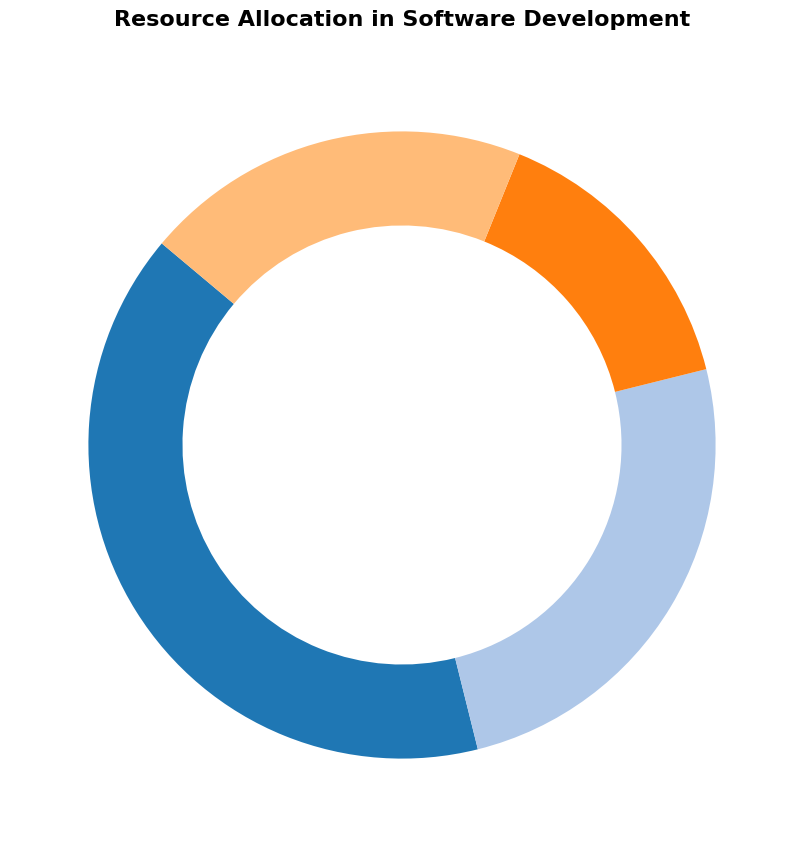What's the largest portion allocated to any activity? By looking at the pie chart, you can see that Development has the largest wedge, representing 40% of the total allocation.
Answer: Development, 40% What's the total percentage allocated to Testing and Deployment? Add the percentages for Testing (25%) and Deployment (15%). The total allocation for these two activities is 25% + 15% = 40%.
Answer: 40% What is the smallest allocation among the activities? By viewing each wedge, Deployment has the smallest allocation at 15%.
Answer: Deployment, 15% Which activity has a greater allocation: Maintenance or Testing? Compare the percentages of Maintenance (20%) and Testing (25%). Testing has a greater allocation.
Answer: Testing What is the difference in allocation between Development and Maintenance? Subtract the percentage of Maintenance (20%) from Development (40%). The difference is 40% - 20% = 20%.
Answer: 20% What is the total percentage allocated to activities other than Development? Subtract the Development allocation (40%) from 100% to find the total allocation for the other activities. 100% - 40% = 60%.
Answer: 60% Does any activity have an equal percentage to the combined total of two other activities? By adding different combinations, the Testing (25%) and Deployment (15%) together equal Development (40%), thus they are equivalent.
Answer: Yes, Testing and Deployment combined equal Development Which activity is represented by the most vibrant color in the chart? Although individual color preferences vary, the pie chart uses a colorblind-friendly palette. Assistance would be required to identify specific colors unless detailed visually. Let’s assume a theoretical association such as a primary color like red to answer definitively.
Answer: Context-dependent based on a related color schema Does the sum of the Testing and Maintenance allocations exceed the Deployment allocation? Add the Testing (25%) and Maintenance (20%) allocations. Their combined total is 25% + 20% = 45%, which is greater than 15% allocation for Deployment.
Answer: Yes, 45% exceeds 15% How much more percentage is allocated to Development compared to Deployment? Subtract the Deployment allocation (15%) from the Development allocation (40%). The difference is 40% - 15% = 25%.
Answer: 25% 